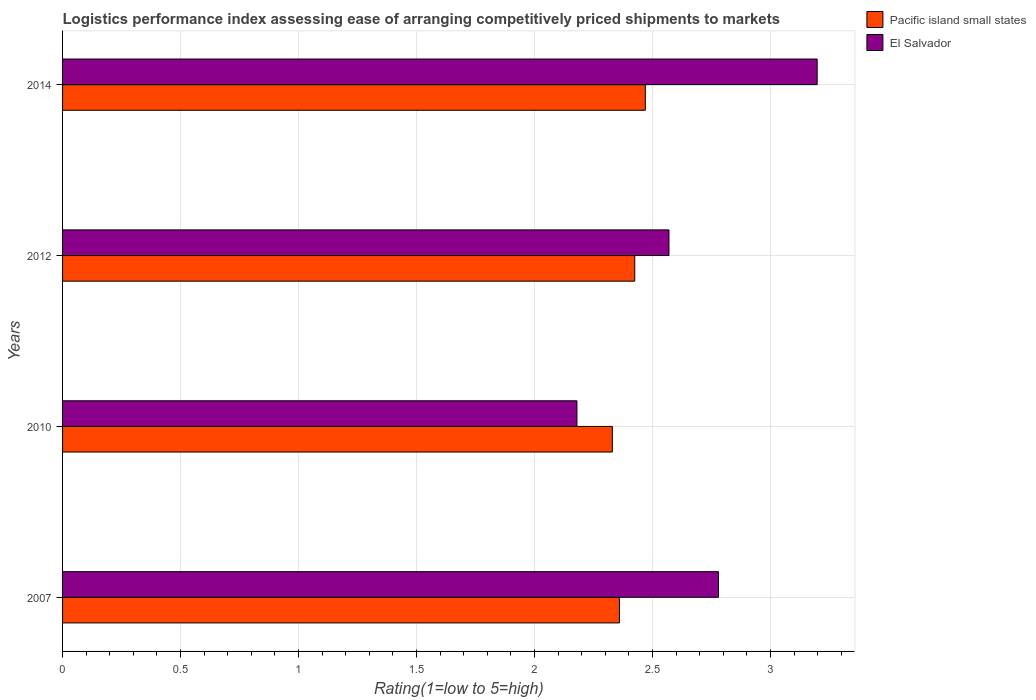How many different coloured bars are there?
Make the answer very short. 2. How many groups of bars are there?
Give a very brief answer. 4. Are the number of bars per tick equal to the number of legend labels?
Your answer should be very brief. Yes. Are the number of bars on each tick of the Y-axis equal?
Provide a succinct answer. Yes. How many bars are there on the 3rd tick from the bottom?
Ensure brevity in your answer.  2. What is the label of the 4th group of bars from the top?
Keep it short and to the point. 2007. What is the Logistic performance index in El Salvador in 2007?
Your answer should be compact. 2.78. Across all years, what is the maximum Logistic performance index in El Salvador?
Keep it short and to the point. 3.2. Across all years, what is the minimum Logistic performance index in El Salvador?
Offer a terse response. 2.18. In which year was the Logistic performance index in El Salvador maximum?
Give a very brief answer. 2014. What is the total Logistic performance index in Pacific island small states in the graph?
Make the answer very short. 9.58. What is the difference between the Logistic performance index in El Salvador in 2007 and that in 2014?
Offer a very short reply. -0.42. What is the difference between the Logistic performance index in El Salvador in 2010 and the Logistic performance index in Pacific island small states in 2007?
Give a very brief answer. -0.18. What is the average Logistic performance index in Pacific island small states per year?
Offer a terse response. 2.4. In the year 2010, what is the difference between the Logistic performance index in El Salvador and Logistic performance index in Pacific island small states?
Ensure brevity in your answer.  -0.15. What is the ratio of the Logistic performance index in El Salvador in 2007 to that in 2010?
Provide a succinct answer. 1.28. Is the Logistic performance index in El Salvador in 2007 less than that in 2012?
Provide a succinct answer. No. Is the difference between the Logistic performance index in El Salvador in 2007 and 2010 greater than the difference between the Logistic performance index in Pacific island small states in 2007 and 2010?
Your answer should be compact. Yes. What is the difference between the highest and the second highest Logistic performance index in El Salvador?
Offer a very short reply. 0.42. What is the difference between the highest and the lowest Logistic performance index in Pacific island small states?
Your answer should be compact. 0.14. What does the 2nd bar from the top in 2007 represents?
Offer a terse response. Pacific island small states. What does the 2nd bar from the bottom in 2014 represents?
Provide a succinct answer. El Salvador. How many bars are there?
Provide a short and direct response. 8. Are all the bars in the graph horizontal?
Offer a very short reply. Yes. How many years are there in the graph?
Keep it short and to the point. 4. Are the values on the major ticks of X-axis written in scientific E-notation?
Provide a short and direct response. No. Does the graph contain any zero values?
Make the answer very short. No. Does the graph contain grids?
Provide a succinct answer. Yes. How many legend labels are there?
Provide a short and direct response. 2. How are the legend labels stacked?
Your answer should be compact. Vertical. What is the title of the graph?
Offer a terse response. Logistics performance index assessing ease of arranging competitively priced shipments to markets. Does "Vanuatu" appear as one of the legend labels in the graph?
Your response must be concise. No. What is the label or title of the X-axis?
Your response must be concise. Rating(1=low to 5=high). What is the Rating(1=low to 5=high) in Pacific island small states in 2007?
Offer a very short reply. 2.36. What is the Rating(1=low to 5=high) in El Salvador in 2007?
Give a very brief answer. 2.78. What is the Rating(1=low to 5=high) in Pacific island small states in 2010?
Provide a short and direct response. 2.33. What is the Rating(1=low to 5=high) of El Salvador in 2010?
Your answer should be compact. 2.18. What is the Rating(1=low to 5=high) of Pacific island small states in 2012?
Offer a terse response. 2.42. What is the Rating(1=low to 5=high) in El Salvador in 2012?
Your response must be concise. 2.57. What is the Rating(1=low to 5=high) in Pacific island small states in 2014?
Make the answer very short. 2.47. What is the Rating(1=low to 5=high) of El Salvador in 2014?
Keep it short and to the point. 3.2. Across all years, what is the maximum Rating(1=low to 5=high) in Pacific island small states?
Your answer should be compact. 2.47. Across all years, what is the maximum Rating(1=low to 5=high) in El Salvador?
Give a very brief answer. 3.2. Across all years, what is the minimum Rating(1=low to 5=high) of Pacific island small states?
Make the answer very short. 2.33. Across all years, what is the minimum Rating(1=low to 5=high) in El Salvador?
Provide a succinct answer. 2.18. What is the total Rating(1=low to 5=high) of Pacific island small states in the graph?
Your response must be concise. 9.58. What is the total Rating(1=low to 5=high) in El Salvador in the graph?
Give a very brief answer. 10.73. What is the difference between the Rating(1=low to 5=high) of Pacific island small states in 2007 and that in 2010?
Your answer should be very brief. 0.03. What is the difference between the Rating(1=low to 5=high) in Pacific island small states in 2007 and that in 2012?
Provide a short and direct response. -0.07. What is the difference between the Rating(1=low to 5=high) in El Salvador in 2007 and that in 2012?
Offer a terse response. 0.21. What is the difference between the Rating(1=low to 5=high) in Pacific island small states in 2007 and that in 2014?
Your answer should be compact. -0.11. What is the difference between the Rating(1=low to 5=high) of El Salvador in 2007 and that in 2014?
Make the answer very short. -0.42. What is the difference between the Rating(1=low to 5=high) of Pacific island small states in 2010 and that in 2012?
Your response must be concise. -0.1. What is the difference between the Rating(1=low to 5=high) of El Salvador in 2010 and that in 2012?
Provide a short and direct response. -0.39. What is the difference between the Rating(1=low to 5=high) of Pacific island small states in 2010 and that in 2014?
Ensure brevity in your answer.  -0.14. What is the difference between the Rating(1=low to 5=high) in El Salvador in 2010 and that in 2014?
Keep it short and to the point. -1.02. What is the difference between the Rating(1=low to 5=high) of Pacific island small states in 2012 and that in 2014?
Your answer should be compact. -0.04. What is the difference between the Rating(1=low to 5=high) of El Salvador in 2012 and that in 2014?
Your answer should be very brief. -0.63. What is the difference between the Rating(1=low to 5=high) of Pacific island small states in 2007 and the Rating(1=low to 5=high) of El Salvador in 2010?
Provide a short and direct response. 0.18. What is the difference between the Rating(1=low to 5=high) of Pacific island small states in 2007 and the Rating(1=low to 5=high) of El Salvador in 2012?
Your response must be concise. -0.21. What is the difference between the Rating(1=low to 5=high) in Pacific island small states in 2007 and the Rating(1=low to 5=high) in El Salvador in 2014?
Provide a succinct answer. -0.84. What is the difference between the Rating(1=low to 5=high) of Pacific island small states in 2010 and the Rating(1=low to 5=high) of El Salvador in 2012?
Ensure brevity in your answer.  -0.24. What is the difference between the Rating(1=low to 5=high) in Pacific island small states in 2010 and the Rating(1=low to 5=high) in El Salvador in 2014?
Your response must be concise. -0.87. What is the difference between the Rating(1=low to 5=high) of Pacific island small states in 2012 and the Rating(1=low to 5=high) of El Salvador in 2014?
Your answer should be very brief. -0.77. What is the average Rating(1=low to 5=high) of Pacific island small states per year?
Ensure brevity in your answer.  2.4. What is the average Rating(1=low to 5=high) in El Salvador per year?
Provide a short and direct response. 2.68. In the year 2007, what is the difference between the Rating(1=low to 5=high) in Pacific island small states and Rating(1=low to 5=high) in El Salvador?
Make the answer very short. -0.42. In the year 2012, what is the difference between the Rating(1=low to 5=high) of Pacific island small states and Rating(1=low to 5=high) of El Salvador?
Provide a short and direct response. -0.14. In the year 2014, what is the difference between the Rating(1=low to 5=high) in Pacific island small states and Rating(1=low to 5=high) in El Salvador?
Offer a very short reply. -0.73. What is the ratio of the Rating(1=low to 5=high) of Pacific island small states in 2007 to that in 2010?
Provide a succinct answer. 1.01. What is the ratio of the Rating(1=low to 5=high) of El Salvador in 2007 to that in 2010?
Ensure brevity in your answer.  1.28. What is the ratio of the Rating(1=low to 5=high) in Pacific island small states in 2007 to that in 2012?
Your answer should be compact. 0.97. What is the ratio of the Rating(1=low to 5=high) in El Salvador in 2007 to that in 2012?
Offer a terse response. 1.08. What is the ratio of the Rating(1=low to 5=high) of Pacific island small states in 2007 to that in 2014?
Your answer should be compact. 0.96. What is the ratio of the Rating(1=low to 5=high) of El Salvador in 2007 to that in 2014?
Your response must be concise. 0.87. What is the ratio of the Rating(1=low to 5=high) in Pacific island small states in 2010 to that in 2012?
Give a very brief answer. 0.96. What is the ratio of the Rating(1=low to 5=high) in El Salvador in 2010 to that in 2012?
Make the answer very short. 0.85. What is the ratio of the Rating(1=low to 5=high) in Pacific island small states in 2010 to that in 2014?
Your answer should be compact. 0.94. What is the ratio of the Rating(1=low to 5=high) of El Salvador in 2010 to that in 2014?
Give a very brief answer. 0.68. What is the ratio of the Rating(1=low to 5=high) of Pacific island small states in 2012 to that in 2014?
Offer a terse response. 0.98. What is the ratio of the Rating(1=low to 5=high) in El Salvador in 2012 to that in 2014?
Your response must be concise. 0.8. What is the difference between the highest and the second highest Rating(1=low to 5=high) in Pacific island small states?
Offer a very short reply. 0.04. What is the difference between the highest and the second highest Rating(1=low to 5=high) of El Salvador?
Make the answer very short. 0.42. What is the difference between the highest and the lowest Rating(1=low to 5=high) of Pacific island small states?
Ensure brevity in your answer.  0.14. What is the difference between the highest and the lowest Rating(1=low to 5=high) of El Salvador?
Your answer should be compact. 1.02. 